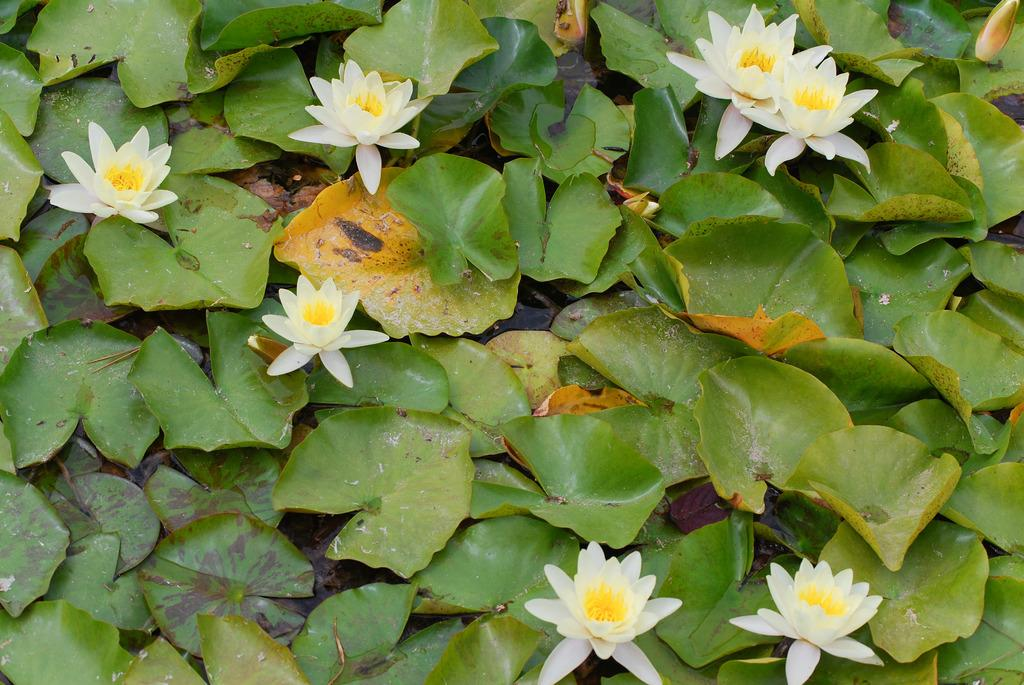What type of plants can be seen in the image? There are flowers and leaves in the image. What else is visible in the image besides plants? There is water visible in the image. Can you see a worm crawling on the leaves in the image? There is no worm present in the image; it only features flowers, leaves, and water. 